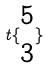Convert formula to latex. <formula><loc_0><loc_0><loc_500><loc_500>t \{ \begin{matrix} 5 \\ 3 \end{matrix} \}</formula> 